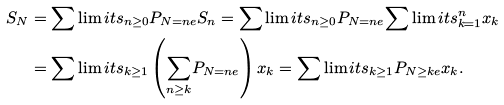<formula> <loc_0><loc_0><loc_500><loc_500>S _ { N } & = { \sum \lim i t s _ { n \geq 0 } } P _ { N = n e } S _ { n } = { \sum \lim i t s _ { n \geq 0 } } P _ { N = n e } { \sum \lim i t s _ { k = 1 } ^ { n } } x _ { k } \\ & = { \sum \lim i t s _ { k \geq 1 } } \left ( { \sum _ { n \geq k } } P _ { N = n e } \right ) x _ { k } = { \sum \lim i t s _ { k \geq 1 } } P _ { N \geq k e } x _ { k } .</formula> 